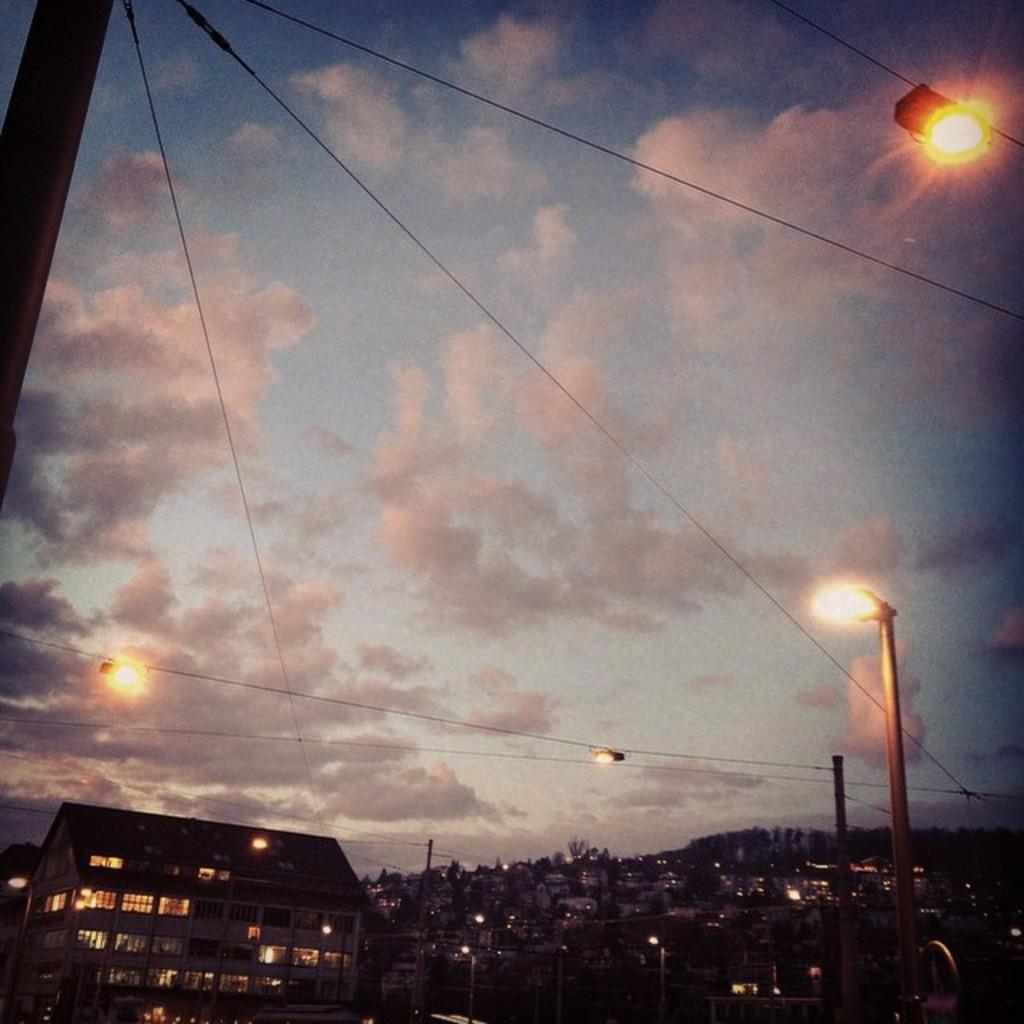What can be seen in the sky in the image? The sky with clouds is visible in the image. What type of lighting is present in the image? Electric lights are present in the image. What infrastructure is related to the electric lights in the image? Electric cables and electric poles are visible in the image. What type of structures are visible in the image? Buildings are visible in the image. What type of cooking equipment is present in the image? Grills are present in the image. What type of cushion is being used to prop up the soda in the image? There is no cushion or soda present in the image. What type of paste is being used to stick the buildings together in the image? There is no paste or indication of buildings being stuck together in the image. 